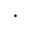Convert formula to latex. <formula><loc_0><loc_0><loc_500><loc_500>\cdot</formula> 